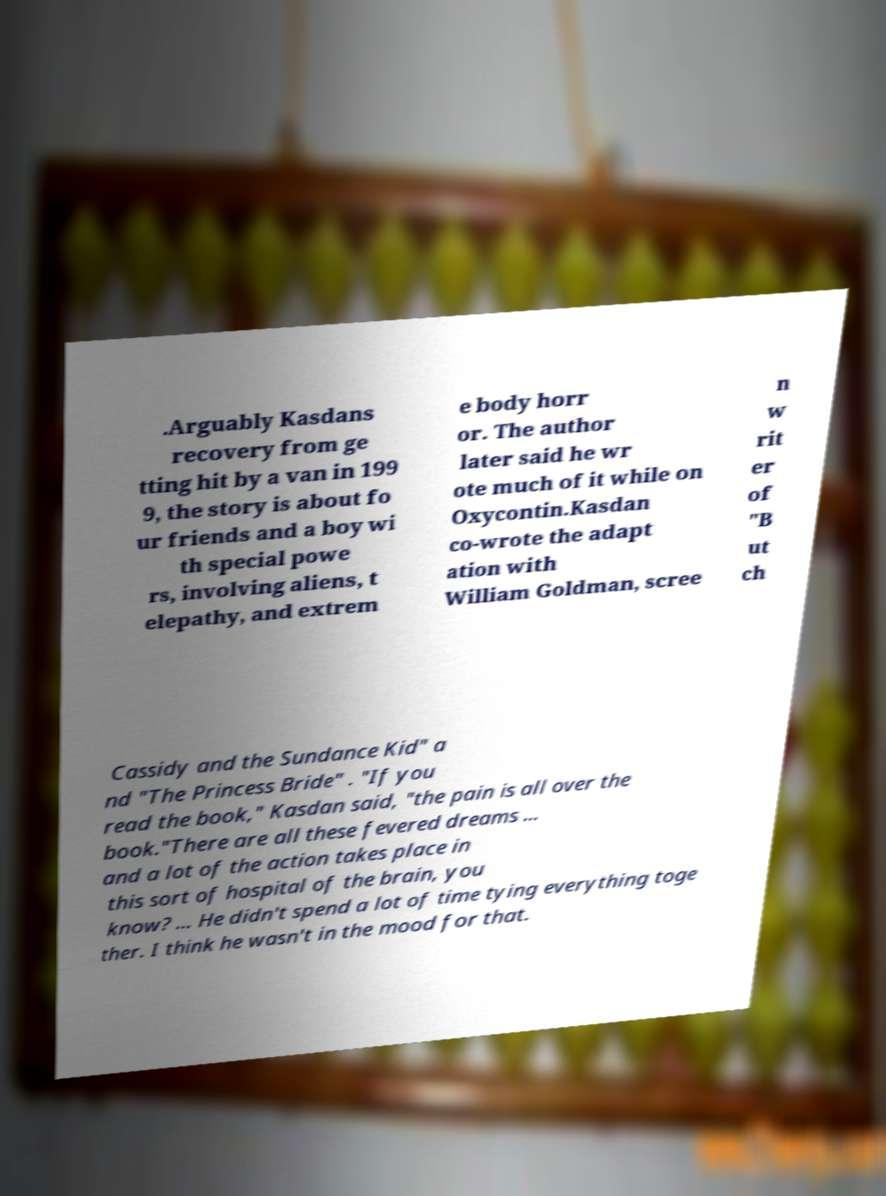Please read and relay the text visible in this image. What does it say? .Arguably Kasdans recovery from ge tting hit by a van in 199 9, the story is about fo ur friends and a boy wi th special powe rs, involving aliens, t elepathy, and extrem e body horr or. The author later said he wr ote much of it while on Oxycontin.Kasdan co-wrote the adapt ation with William Goldman, scree n w rit er of "B ut ch Cassidy and the Sundance Kid" a nd "The Princess Bride" . "If you read the book," Kasdan said, "the pain is all over the book."There are all these fevered dreams ... and a lot of the action takes place in this sort of hospital of the brain, you know? ... He didn't spend a lot of time tying everything toge ther. I think he wasn't in the mood for that. 